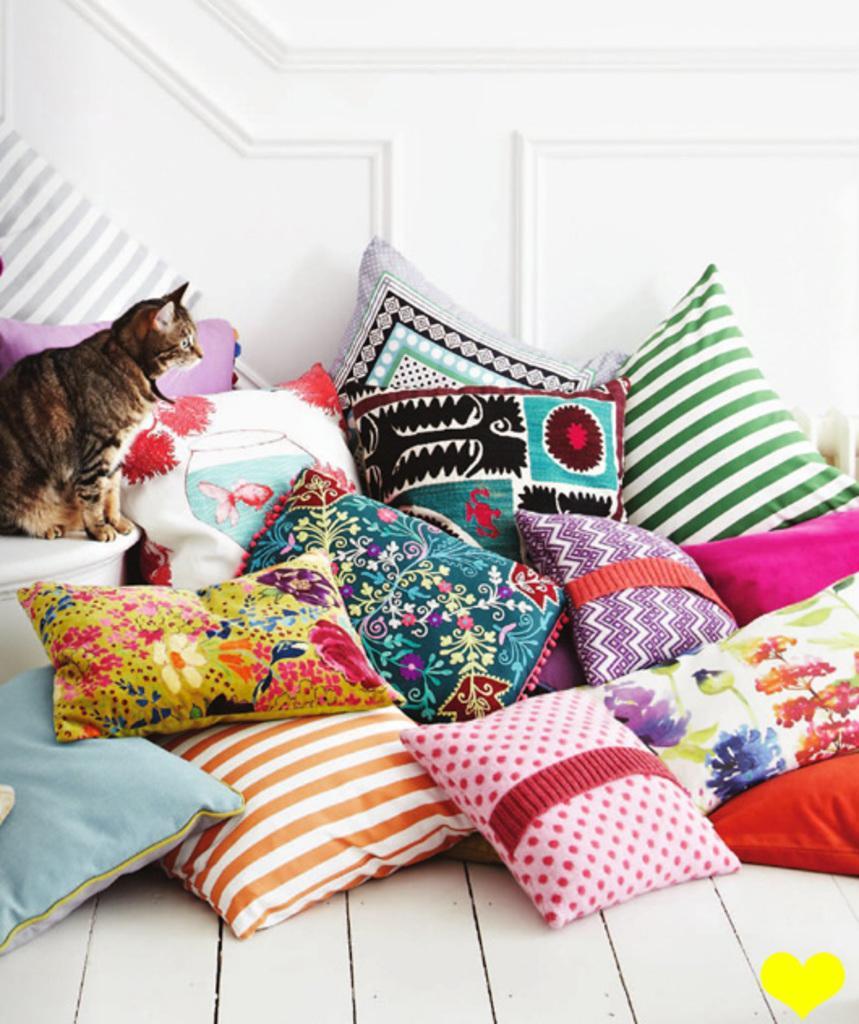How would you summarize this image in a sentence or two? In this image there are pillows, wall, cat and floor. At the bottom of the image there is a logo.   